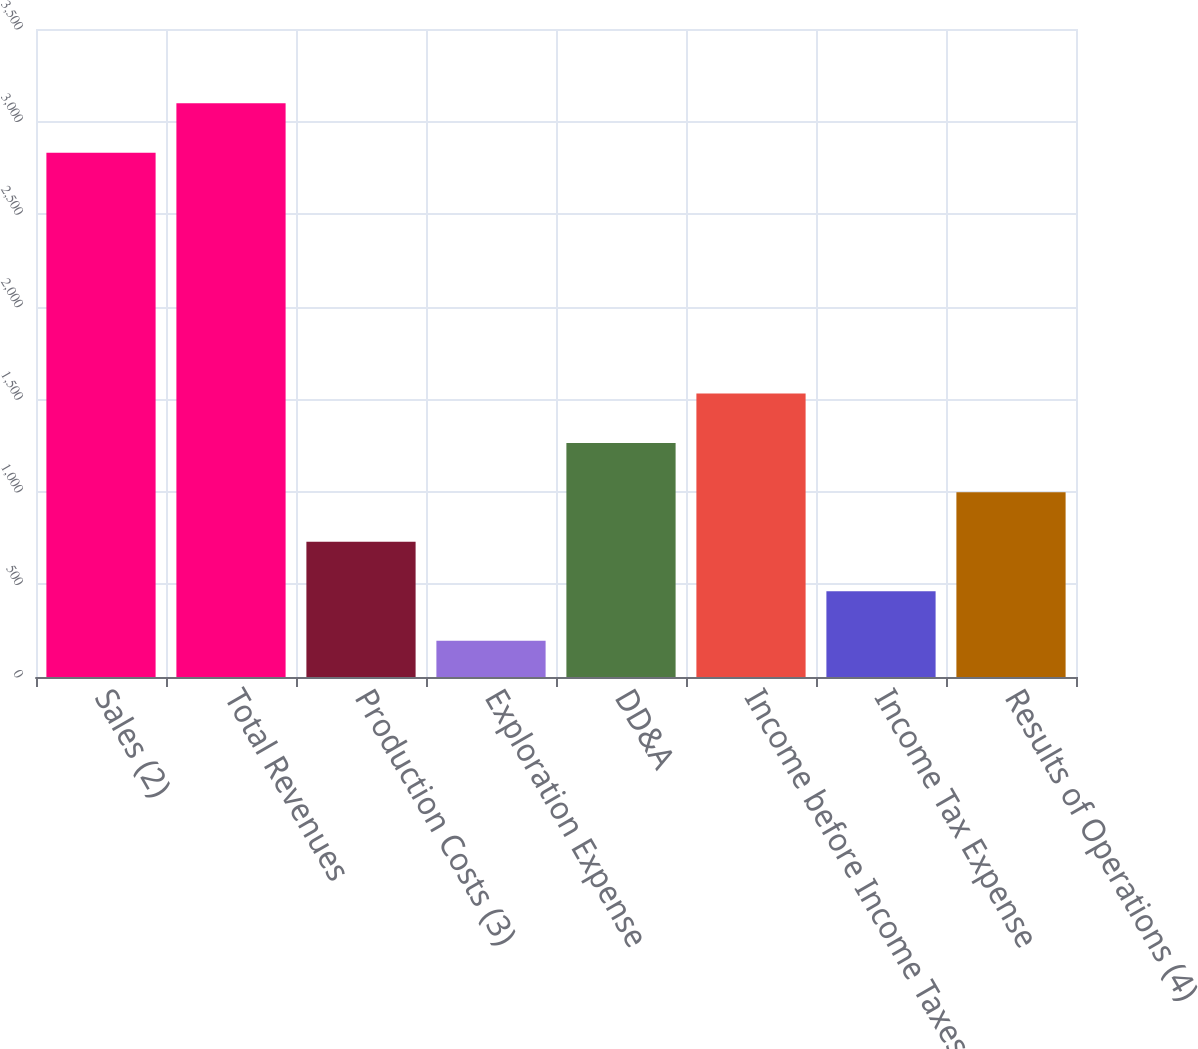<chart> <loc_0><loc_0><loc_500><loc_500><bar_chart><fcel>Sales (2)<fcel>Total Revenues<fcel>Production Costs (3)<fcel>Exploration Expense<fcel>DD&A<fcel>Income before Income Taxes<fcel>Income Tax Expense<fcel>Results of Operations (4)<nl><fcel>2832<fcel>3099.1<fcel>730.2<fcel>196<fcel>1264.4<fcel>1531.5<fcel>463.1<fcel>997.3<nl></chart> 